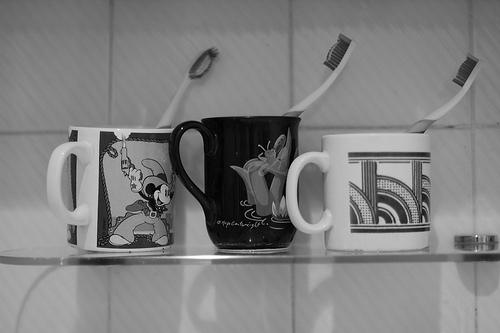Question: how many black cups are there?
Choices:
A. Two.
B. One.
C. Three.
D. Four.
Answer with the letter. Answer: B Question: what colors is the photo?
Choices:
A. Red and blue.
B. Pink and purple.
C. Yellow and orange.
D. Black and white.
Answer with the letter. Answer: D Question: who is on the left cup?
Choices:
A. Mickey Mouse.
B. Minnie Mouse.
C. Donald Duck.
D. Goofy.
Answer with the letter. Answer: A Question: where was the photo taken?
Choices:
A. In the kitchen.
B. In the bathroom.
C. In the living room.
D. In the dining room.
Answer with the letter. Answer: B Question: what is on the wall?
Choices:
A. Pictures.
B. Tile.
C. Calendar.
D. Clock.
Answer with the letter. Answer: B Question: what is created by the cups?
Choices:
A. Shadows.
B. Tower.
C. Wall.
D. Triangle.
Answer with the letter. Answer: A 